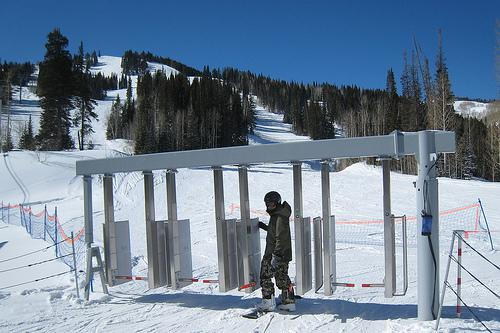Question: who is in the picture?
Choices:
A. A man.
B. A woman.
C. A young boy.
D. A female infant.
Answer with the letter. Answer: A Question: what is on his head?
Choices:
A. A mask.
B. His young daughter.
C. A helmet.
D. A headband.
Answer with the letter. Answer: C 